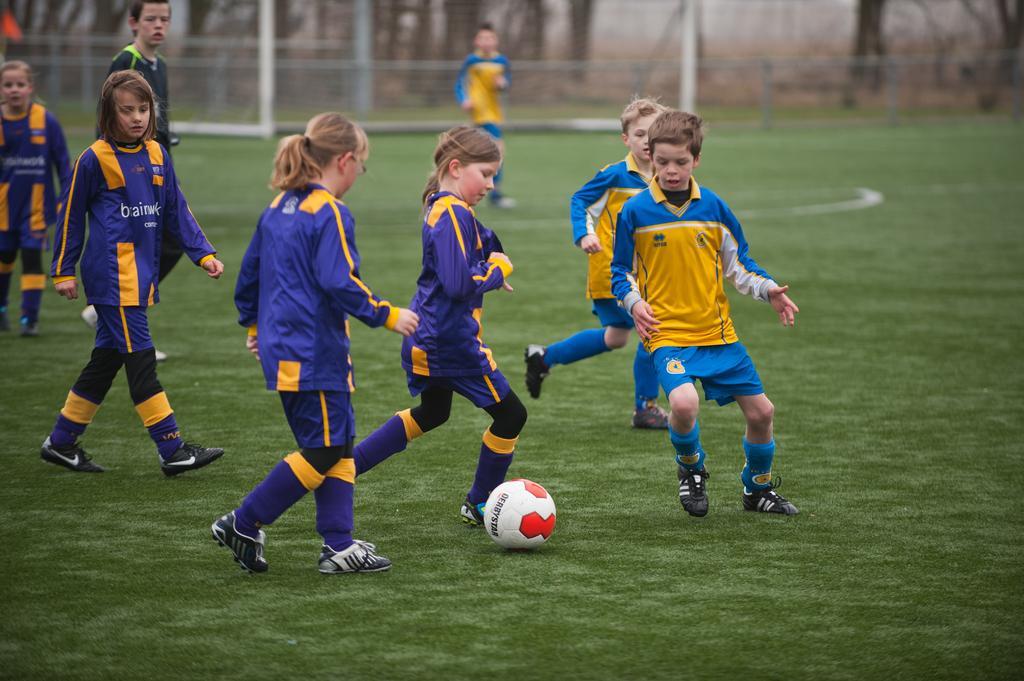How would you summarize this image in a sentence or two? In this picture there are many kids playing and among them there is a blue color team and a violet color team playing. In the background we also observe a goalkeeper standing. 